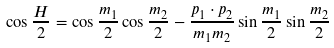<formula> <loc_0><loc_0><loc_500><loc_500>\cos \frac { H } { 2 } = \cos \frac { m _ { 1 } } { 2 } \cos \frac { m _ { 2 } } { 2 } - \frac { p _ { 1 } \cdot p _ { 2 } } { m _ { 1 } m _ { 2 } } \sin \frac { m _ { 1 } } { 2 } \sin \frac { m _ { 2 } } { 2 }</formula> 